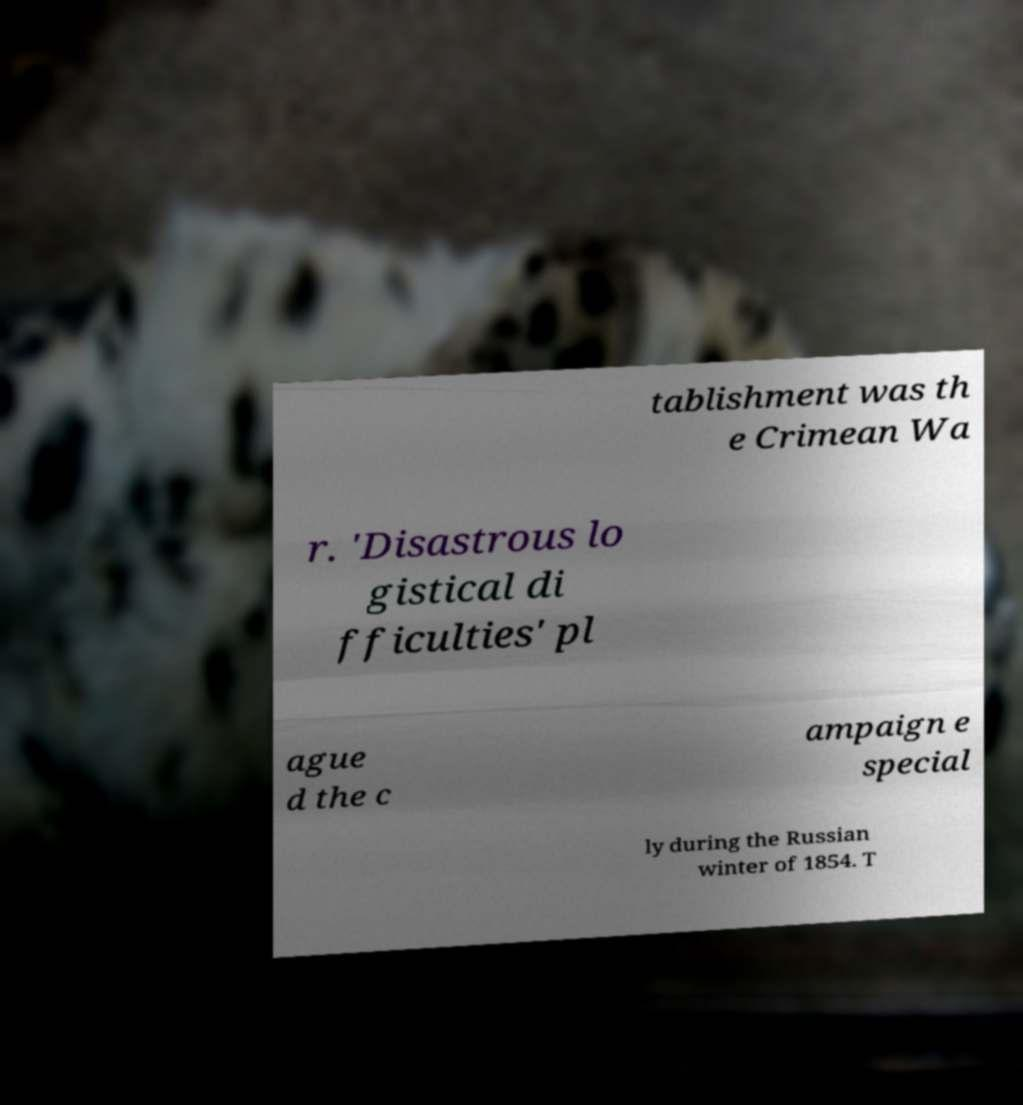Please read and relay the text visible in this image. What does it say? tablishment was th e Crimean Wa r. 'Disastrous lo gistical di fficulties' pl ague d the c ampaign e special ly during the Russian winter of 1854. T 